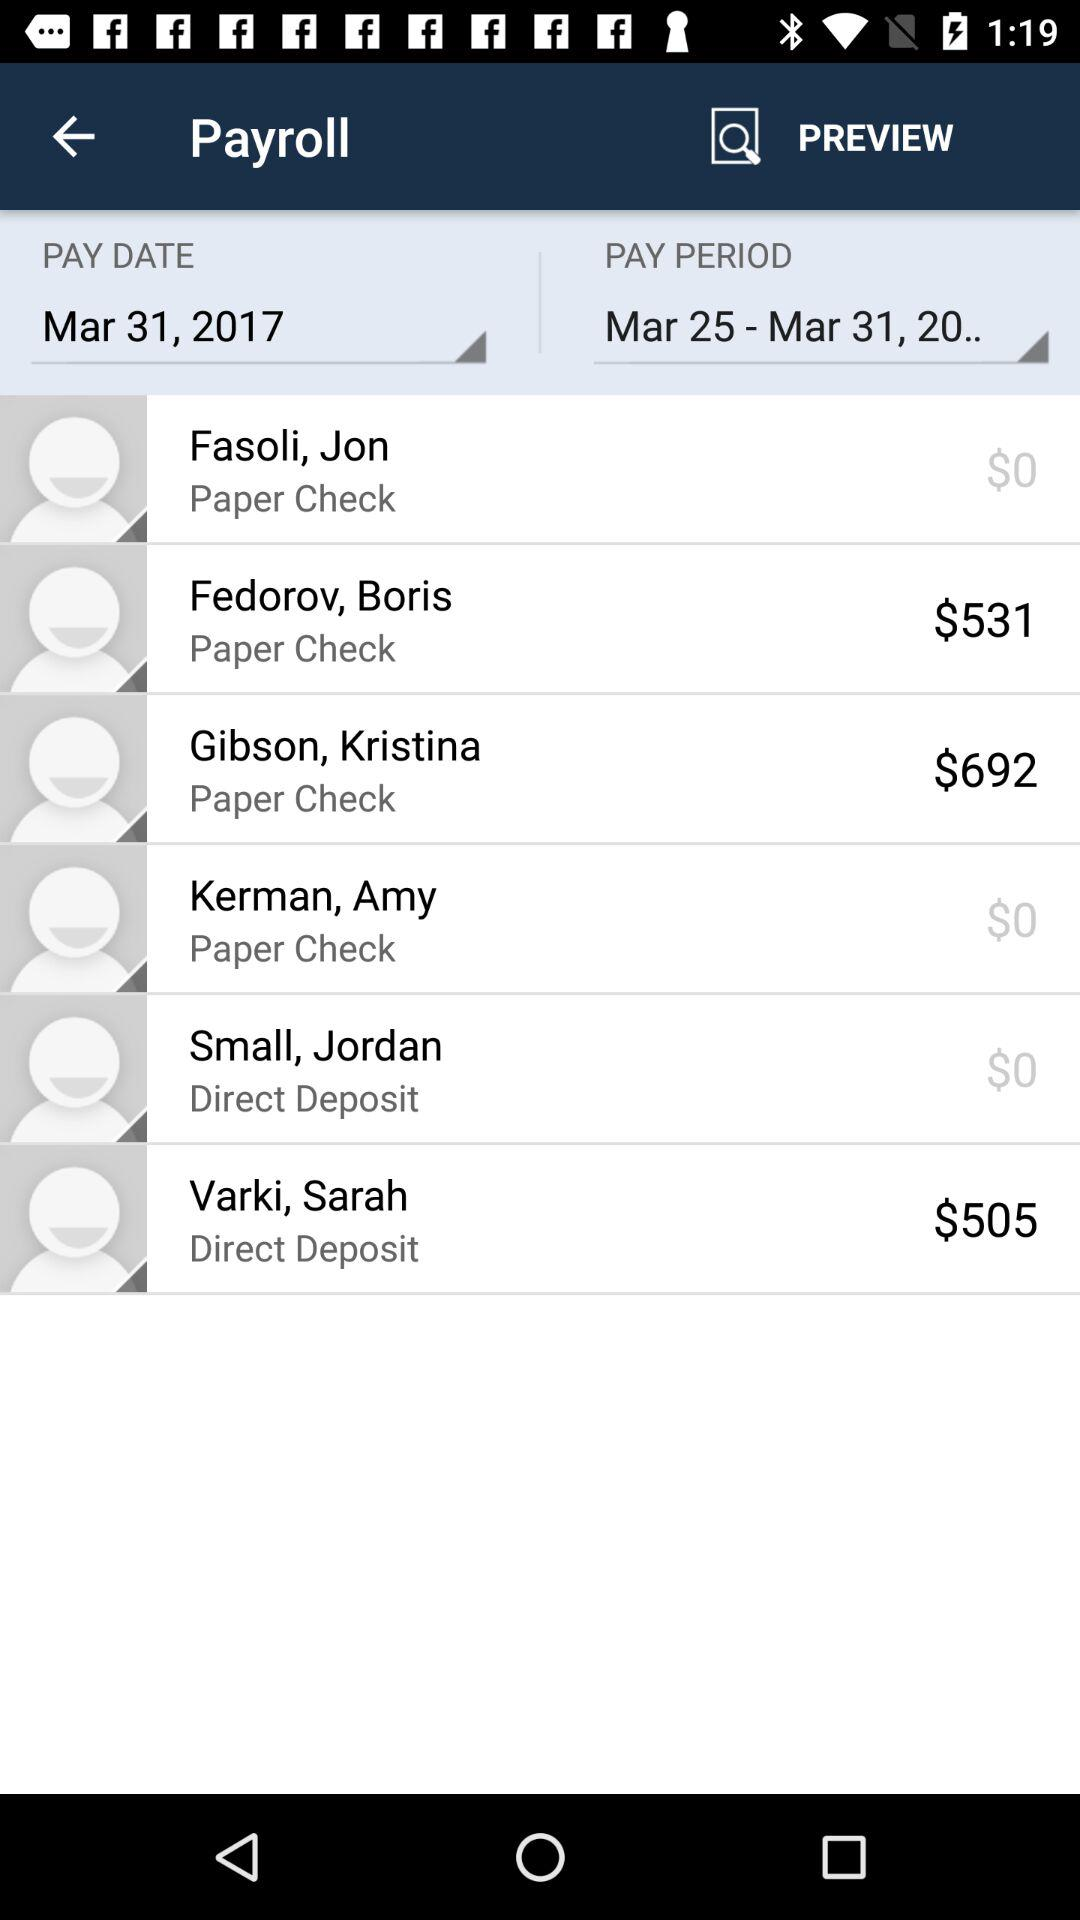How many employees are paid by direct deposit?
Answer the question using a single word or phrase. 2 